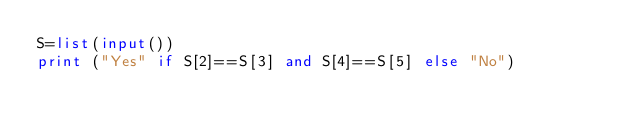<code> <loc_0><loc_0><loc_500><loc_500><_Python_>S=list(input())
print ("Yes" if S[2]==S[3] and S[4]==S[5] else "No")
</code> 